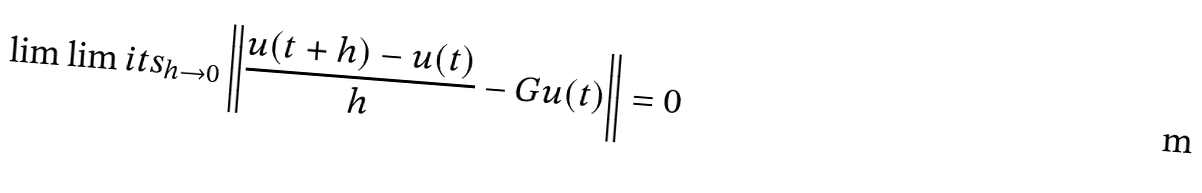Convert formula to latex. <formula><loc_0><loc_0><loc_500><loc_500>\lim \lim i t s _ { h \to 0 } \left \| \frac { u ( t + h ) - u ( t ) } { h } - G u ( t ) \right \| = 0</formula> 